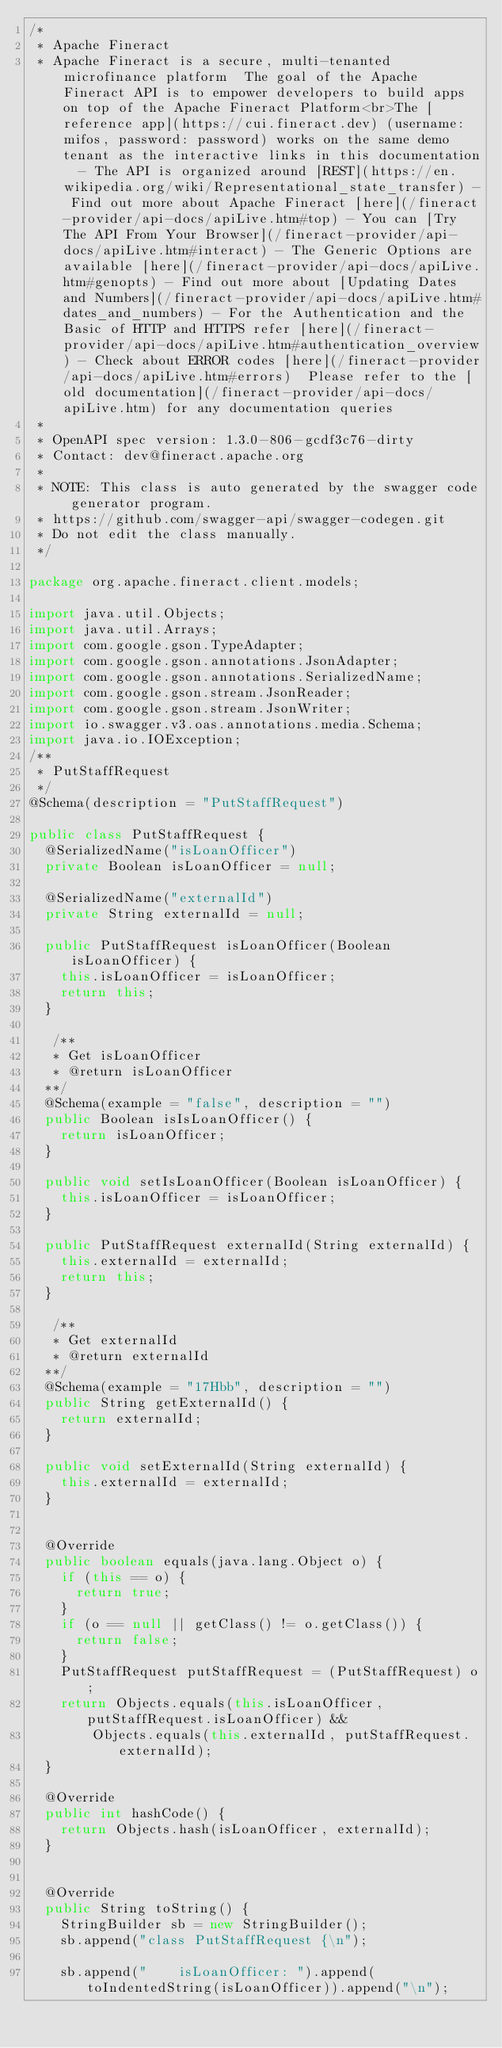<code> <loc_0><loc_0><loc_500><loc_500><_Java_>/*
 * Apache Fineract
 * Apache Fineract is a secure, multi-tenanted microfinance platform  The goal of the Apache Fineract API is to empower developers to build apps on top of the Apache Fineract Platform<br>The [reference app](https://cui.fineract.dev) (username: mifos, password: password) works on the same demo tenant as the interactive links in this documentation  - The API is organized around [REST](https://en.wikipedia.org/wiki/Representational_state_transfer) - Find out more about Apache Fineract [here](/fineract-provider/api-docs/apiLive.htm#top) - You can [Try The API From Your Browser](/fineract-provider/api-docs/apiLive.htm#interact) - The Generic Options are available [here](/fineract-provider/api-docs/apiLive.htm#genopts) - Find out more about [Updating Dates and Numbers](/fineract-provider/api-docs/apiLive.htm#dates_and_numbers) - For the Authentication and the Basic of HTTP and HTTPS refer [here](/fineract-provider/api-docs/apiLive.htm#authentication_overview) - Check about ERROR codes [here](/fineract-provider/api-docs/apiLive.htm#errors)  Please refer to the [old documentation](/fineract-provider/api-docs/apiLive.htm) for any documentation queries
 *
 * OpenAPI spec version: 1.3.0-806-gcdf3c76-dirty
 * Contact: dev@fineract.apache.org
 *
 * NOTE: This class is auto generated by the swagger code generator program.
 * https://github.com/swagger-api/swagger-codegen.git
 * Do not edit the class manually.
 */

package org.apache.fineract.client.models;

import java.util.Objects;
import java.util.Arrays;
import com.google.gson.TypeAdapter;
import com.google.gson.annotations.JsonAdapter;
import com.google.gson.annotations.SerializedName;
import com.google.gson.stream.JsonReader;
import com.google.gson.stream.JsonWriter;
import io.swagger.v3.oas.annotations.media.Schema;
import java.io.IOException;
/**
 * PutStaffRequest
 */
@Schema(description = "PutStaffRequest")

public class PutStaffRequest {
  @SerializedName("isLoanOfficer")
  private Boolean isLoanOfficer = null;

  @SerializedName("externalId")
  private String externalId = null;

  public PutStaffRequest isLoanOfficer(Boolean isLoanOfficer) {
    this.isLoanOfficer = isLoanOfficer;
    return this;
  }

   /**
   * Get isLoanOfficer
   * @return isLoanOfficer
  **/
  @Schema(example = "false", description = "")
  public Boolean isIsLoanOfficer() {
    return isLoanOfficer;
  }

  public void setIsLoanOfficer(Boolean isLoanOfficer) {
    this.isLoanOfficer = isLoanOfficer;
  }

  public PutStaffRequest externalId(String externalId) {
    this.externalId = externalId;
    return this;
  }

   /**
   * Get externalId
   * @return externalId
  **/
  @Schema(example = "17Hbb", description = "")
  public String getExternalId() {
    return externalId;
  }

  public void setExternalId(String externalId) {
    this.externalId = externalId;
  }


  @Override
  public boolean equals(java.lang.Object o) {
    if (this == o) {
      return true;
    }
    if (o == null || getClass() != o.getClass()) {
      return false;
    }
    PutStaffRequest putStaffRequest = (PutStaffRequest) o;
    return Objects.equals(this.isLoanOfficer, putStaffRequest.isLoanOfficer) &&
        Objects.equals(this.externalId, putStaffRequest.externalId);
  }

  @Override
  public int hashCode() {
    return Objects.hash(isLoanOfficer, externalId);
  }


  @Override
  public String toString() {
    StringBuilder sb = new StringBuilder();
    sb.append("class PutStaffRequest {\n");
    
    sb.append("    isLoanOfficer: ").append(toIndentedString(isLoanOfficer)).append("\n");</code> 